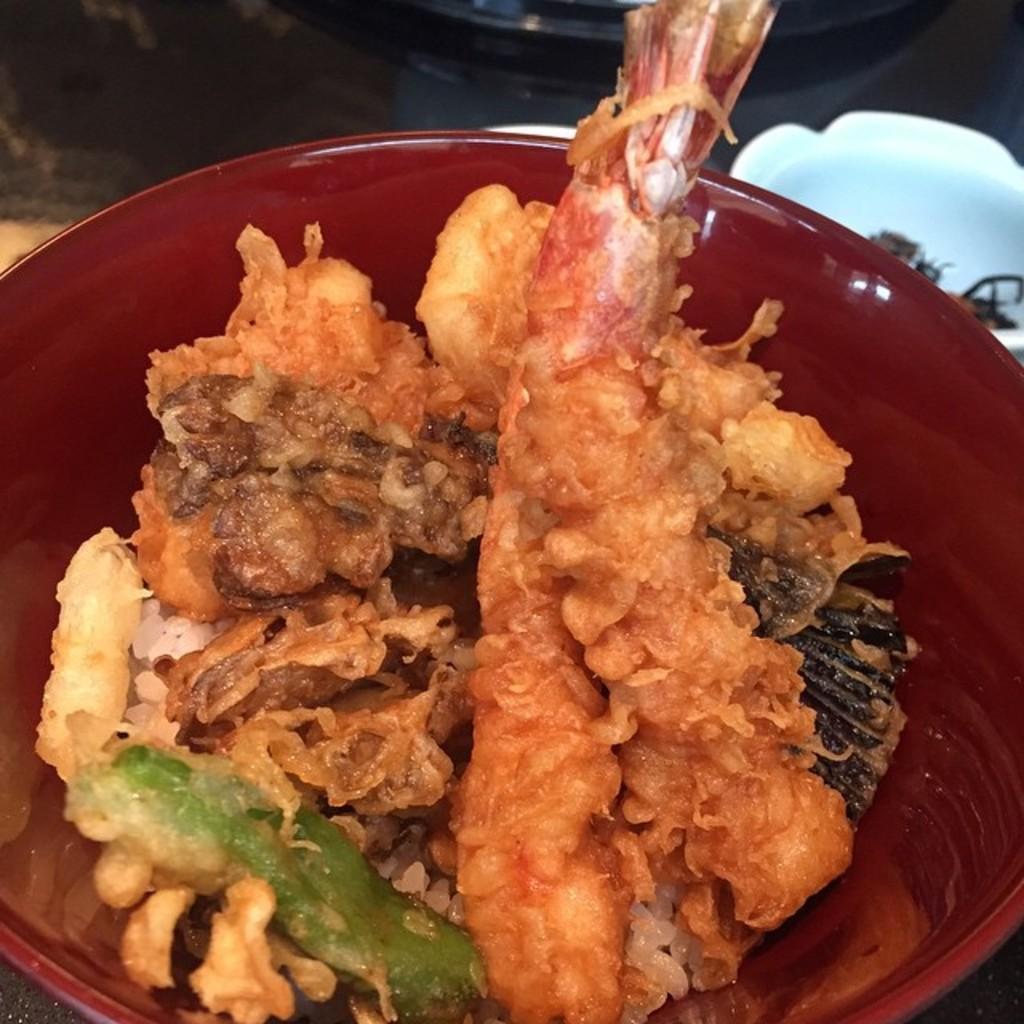Please provide a concise description of this image. In this image we can see food items in a bowl. 